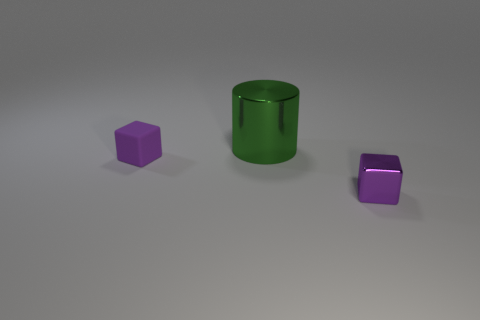Add 3 large green cylinders. How many objects exist? 6 Subtract all cubes. How many objects are left? 1 Add 2 purple rubber things. How many purple rubber things are left? 3 Add 2 large cylinders. How many large cylinders exist? 3 Subtract 0 blue cylinders. How many objects are left? 3 Subtract all gray cylinders. Subtract all brown blocks. How many cylinders are left? 1 Subtract all large things. Subtract all large yellow cylinders. How many objects are left? 2 